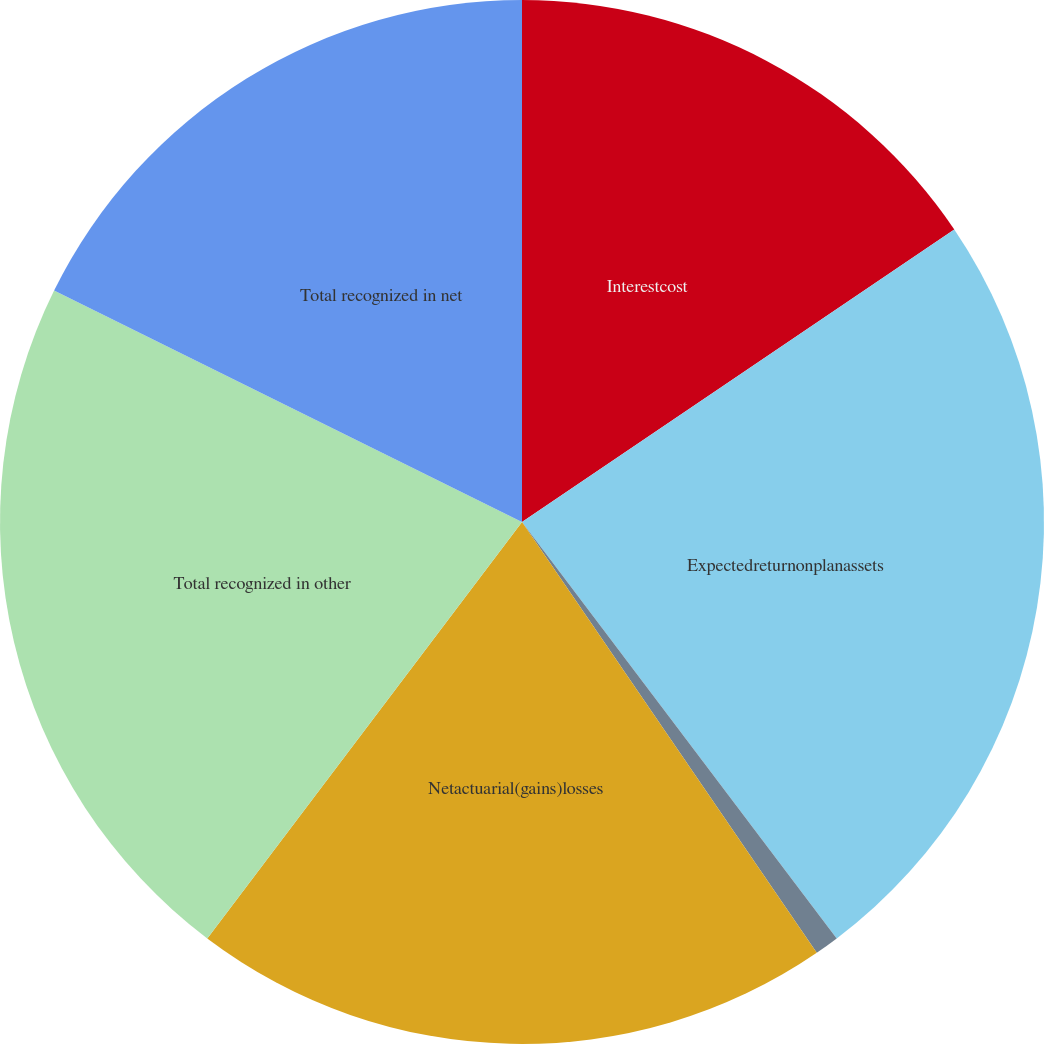Convert chart. <chart><loc_0><loc_0><loc_500><loc_500><pie_chart><fcel>Interestcost<fcel>Expectedreturnonplanassets<fcel>Unnamed: 2<fcel>Netactuarial(gains)losses<fcel>Total recognized in other<fcel>Total recognized in net<nl><fcel>15.53%<fcel>24.17%<fcel>0.75%<fcel>19.85%<fcel>22.01%<fcel>17.69%<nl></chart> 